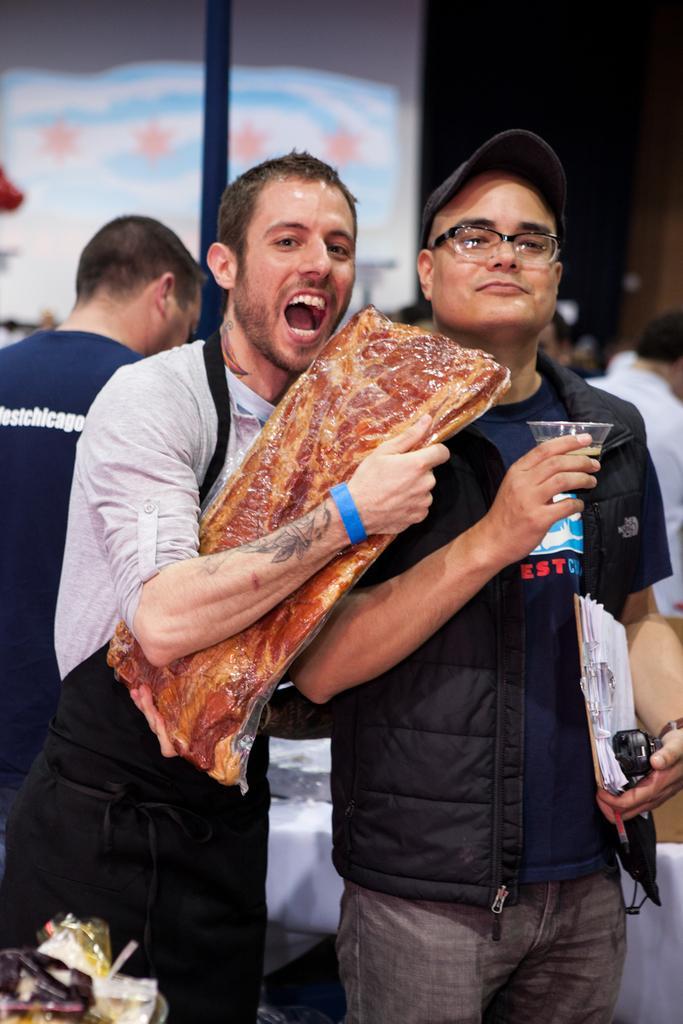Could you give a brief overview of what you see in this image? In this image we can see there are two people standing together where one of them is holding meat and other one holding bowl in one hand and pad with papers and phone on the other. Also there are so many people standing in a group. 